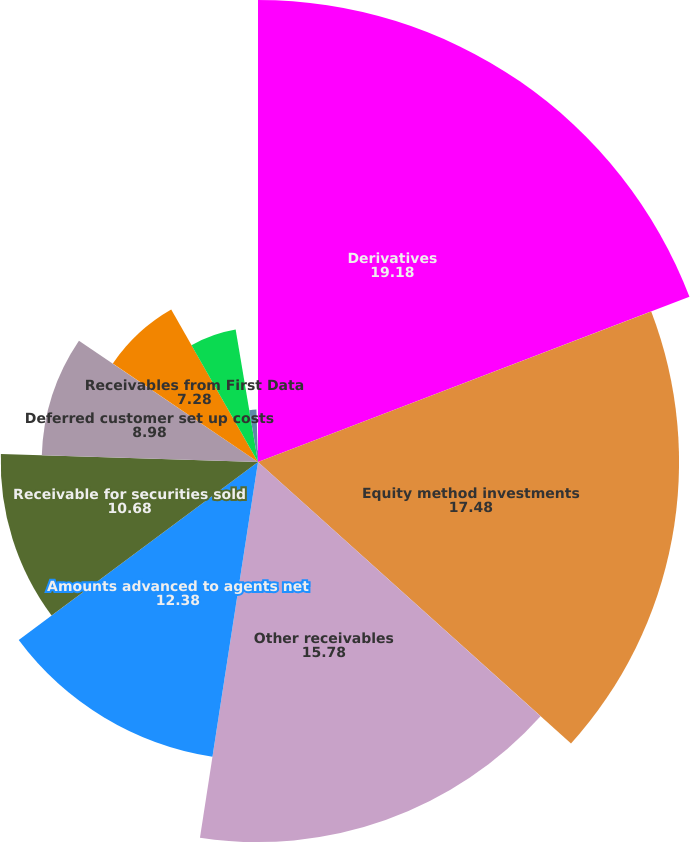<chart> <loc_0><loc_0><loc_500><loc_500><pie_chart><fcel>Derivatives<fcel>Equity method investments<fcel>Other receivables<fcel>Amounts advanced to agents net<fcel>Receivable for securities sold<fcel>Deferred customer set up costs<fcel>Receivables from First Data<fcel>Prepaid expenses<fcel>Debt issue costs<fcel>Accounts receivable net<nl><fcel>19.18%<fcel>17.48%<fcel>15.78%<fcel>12.38%<fcel>10.68%<fcel>8.98%<fcel>7.28%<fcel>5.58%<fcel>2.18%<fcel>0.48%<nl></chart> 